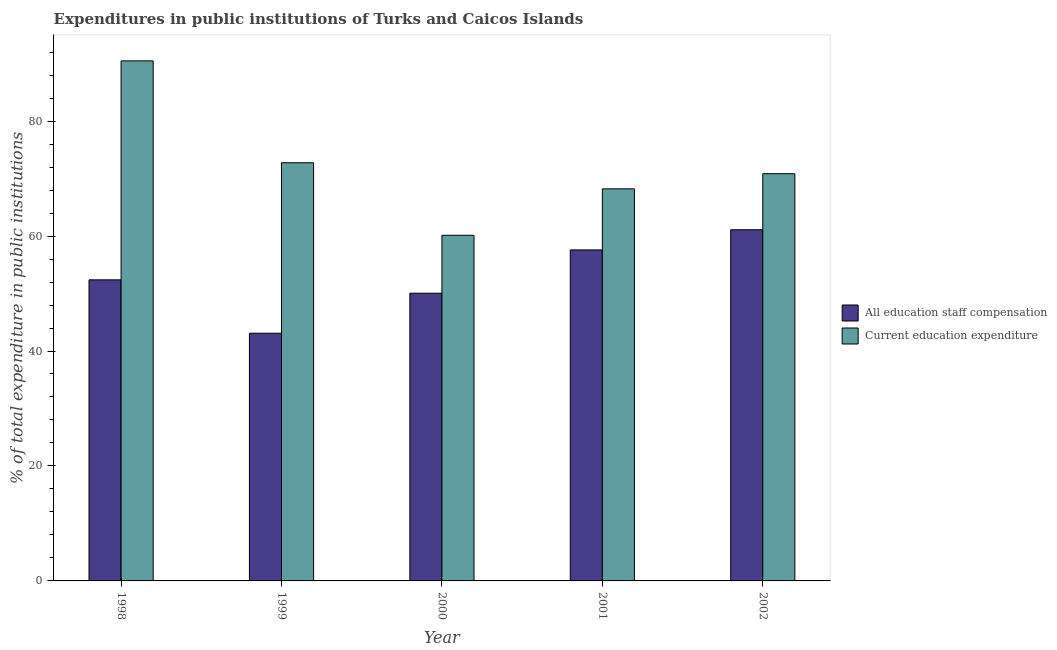How many different coloured bars are there?
Provide a short and direct response. 2. Are the number of bars per tick equal to the number of legend labels?
Your answer should be very brief. Yes. How many bars are there on the 5th tick from the left?
Make the answer very short. 2. What is the label of the 5th group of bars from the left?
Offer a very short reply. 2002. In how many cases, is the number of bars for a given year not equal to the number of legend labels?
Keep it short and to the point. 0. What is the expenditure in education in 2000?
Make the answer very short. 60.13. Across all years, what is the maximum expenditure in education?
Your answer should be very brief. 90.48. Across all years, what is the minimum expenditure in staff compensation?
Ensure brevity in your answer.  43.1. In which year was the expenditure in staff compensation maximum?
Ensure brevity in your answer.  2002. In which year was the expenditure in education minimum?
Keep it short and to the point. 2000. What is the total expenditure in staff compensation in the graph?
Give a very brief answer. 264.22. What is the difference between the expenditure in staff compensation in 2000 and that in 2001?
Your answer should be very brief. -7.53. What is the difference between the expenditure in staff compensation in 2000 and the expenditure in education in 2001?
Your response must be concise. -7.53. What is the average expenditure in staff compensation per year?
Provide a short and direct response. 52.84. What is the ratio of the expenditure in education in 1999 to that in 2001?
Ensure brevity in your answer.  1.07. Is the expenditure in staff compensation in 2000 less than that in 2001?
Provide a succinct answer. Yes. Is the difference between the expenditure in staff compensation in 1999 and 2000 greater than the difference between the expenditure in education in 1999 and 2000?
Ensure brevity in your answer.  No. What is the difference between the highest and the second highest expenditure in staff compensation?
Provide a succinct answer. 3.51. What is the difference between the highest and the lowest expenditure in staff compensation?
Provide a short and direct response. 18. What does the 1st bar from the left in 2000 represents?
Provide a short and direct response. All education staff compensation. What does the 2nd bar from the right in 2001 represents?
Offer a very short reply. All education staff compensation. Are all the bars in the graph horizontal?
Provide a succinct answer. No. What is the difference between two consecutive major ticks on the Y-axis?
Keep it short and to the point. 20. Are the values on the major ticks of Y-axis written in scientific E-notation?
Provide a short and direct response. No. Does the graph contain grids?
Offer a very short reply. No. Where does the legend appear in the graph?
Provide a short and direct response. Center right. What is the title of the graph?
Offer a very short reply. Expenditures in public institutions of Turks and Caicos Islands. Does "Fertility rate" appear as one of the legend labels in the graph?
Provide a short and direct response. No. What is the label or title of the Y-axis?
Ensure brevity in your answer.  % of total expenditure in public institutions. What is the % of total expenditure in public institutions in All education staff compensation in 1998?
Give a very brief answer. 52.38. What is the % of total expenditure in public institutions of Current education expenditure in 1998?
Your response must be concise. 90.48. What is the % of total expenditure in public institutions in All education staff compensation in 1999?
Provide a short and direct response. 43.1. What is the % of total expenditure in public institutions of Current education expenditure in 1999?
Your response must be concise. 72.75. What is the % of total expenditure in public institutions of All education staff compensation in 2000?
Make the answer very short. 50.06. What is the % of total expenditure in public institutions in Current education expenditure in 2000?
Offer a very short reply. 60.13. What is the % of total expenditure in public institutions in All education staff compensation in 2001?
Offer a very short reply. 57.59. What is the % of total expenditure in public institutions of Current education expenditure in 2001?
Keep it short and to the point. 68.21. What is the % of total expenditure in public institutions of All education staff compensation in 2002?
Keep it short and to the point. 61.1. What is the % of total expenditure in public institutions in Current education expenditure in 2002?
Ensure brevity in your answer.  70.85. Across all years, what is the maximum % of total expenditure in public institutions in All education staff compensation?
Provide a succinct answer. 61.1. Across all years, what is the maximum % of total expenditure in public institutions in Current education expenditure?
Your answer should be compact. 90.48. Across all years, what is the minimum % of total expenditure in public institutions in All education staff compensation?
Ensure brevity in your answer.  43.1. Across all years, what is the minimum % of total expenditure in public institutions in Current education expenditure?
Offer a very short reply. 60.13. What is the total % of total expenditure in public institutions in All education staff compensation in the graph?
Offer a very short reply. 264.22. What is the total % of total expenditure in public institutions in Current education expenditure in the graph?
Ensure brevity in your answer.  362.42. What is the difference between the % of total expenditure in public institutions in All education staff compensation in 1998 and that in 1999?
Make the answer very short. 9.28. What is the difference between the % of total expenditure in public institutions of Current education expenditure in 1998 and that in 1999?
Give a very brief answer. 17.72. What is the difference between the % of total expenditure in public institutions of All education staff compensation in 1998 and that in 2000?
Your answer should be very brief. 2.32. What is the difference between the % of total expenditure in public institutions in Current education expenditure in 1998 and that in 2000?
Your answer should be compact. 30.35. What is the difference between the % of total expenditure in public institutions in All education staff compensation in 1998 and that in 2001?
Provide a succinct answer. -5.21. What is the difference between the % of total expenditure in public institutions in Current education expenditure in 1998 and that in 2001?
Ensure brevity in your answer.  22.26. What is the difference between the % of total expenditure in public institutions in All education staff compensation in 1998 and that in 2002?
Make the answer very short. -8.72. What is the difference between the % of total expenditure in public institutions in Current education expenditure in 1998 and that in 2002?
Your answer should be compact. 19.63. What is the difference between the % of total expenditure in public institutions of All education staff compensation in 1999 and that in 2000?
Make the answer very short. -6.96. What is the difference between the % of total expenditure in public institutions in Current education expenditure in 1999 and that in 2000?
Your answer should be very brief. 12.62. What is the difference between the % of total expenditure in public institutions of All education staff compensation in 1999 and that in 2001?
Ensure brevity in your answer.  -14.49. What is the difference between the % of total expenditure in public institutions of Current education expenditure in 1999 and that in 2001?
Provide a short and direct response. 4.54. What is the difference between the % of total expenditure in public institutions of All education staff compensation in 1999 and that in 2002?
Your response must be concise. -18. What is the difference between the % of total expenditure in public institutions in Current education expenditure in 1999 and that in 2002?
Make the answer very short. 1.9. What is the difference between the % of total expenditure in public institutions in All education staff compensation in 2000 and that in 2001?
Your answer should be very brief. -7.53. What is the difference between the % of total expenditure in public institutions of Current education expenditure in 2000 and that in 2001?
Offer a very short reply. -8.08. What is the difference between the % of total expenditure in public institutions of All education staff compensation in 2000 and that in 2002?
Your response must be concise. -11.04. What is the difference between the % of total expenditure in public institutions in Current education expenditure in 2000 and that in 2002?
Offer a very short reply. -10.72. What is the difference between the % of total expenditure in public institutions in All education staff compensation in 2001 and that in 2002?
Ensure brevity in your answer.  -3.51. What is the difference between the % of total expenditure in public institutions in Current education expenditure in 2001 and that in 2002?
Give a very brief answer. -2.64. What is the difference between the % of total expenditure in public institutions of All education staff compensation in 1998 and the % of total expenditure in public institutions of Current education expenditure in 1999?
Keep it short and to the point. -20.37. What is the difference between the % of total expenditure in public institutions in All education staff compensation in 1998 and the % of total expenditure in public institutions in Current education expenditure in 2000?
Make the answer very short. -7.75. What is the difference between the % of total expenditure in public institutions in All education staff compensation in 1998 and the % of total expenditure in public institutions in Current education expenditure in 2001?
Provide a succinct answer. -15.83. What is the difference between the % of total expenditure in public institutions in All education staff compensation in 1998 and the % of total expenditure in public institutions in Current education expenditure in 2002?
Make the answer very short. -18.47. What is the difference between the % of total expenditure in public institutions of All education staff compensation in 1999 and the % of total expenditure in public institutions of Current education expenditure in 2000?
Your response must be concise. -17.03. What is the difference between the % of total expenditure in public institutions of All education staff compensation in 1999 and the % of total expenditure in public institutions of Current education expenditure in 2001?
Ensure brevity in your answer.  -25.12. What is the difference between the % of total expenditure in public institutions in All education staff compensation in 1999 and the % of total expenditure in public institutions in Current education expenditure in 2002?
Provide a short and direct response. -27.75. What is the difference between the % of total expenditure in public institutions of All education staff compensation in 2000 and the % of total expenditure in public institutions of Current education expenditure in 2001?
Give a very brief answer. -18.15. What is the difference between the % of total expenditure in public institutions of All education staff compensation in 2000 and the % of total expenditure in public institutions of Current education expenditure in 2002?
Your response must be concise. -20.79. What is the difference between the % of total expenditure in public institutions in All education staff compensation in 2001 and the % of total expenditure in public institutions in Current education expenditure in 2002?
Make the answer very short. -13.26. What is the average % of total expenditure in public institutions of All education staff compensation per year?
Your answer should be compact. 52.84. What is the average % of total expenditure in public institutions in Current education expenditure per year?
Provide a short and direct response. 72.48. In the year 1998, what is the difference between the % of total expenditure in public institutions in All education staff compensation and % of total expenditure in public institutions in Current education expenditure?
Provide a succinct answer. -38.1. In the year 1999, what is the difference between the % of total expenditure in public institutions in All education staff compensation and % of total expenditure in public institutions in Current education expenditure?
Ensure brevity in your answer.  -29.66. In the year 2000, what is the difference between the % of total expenditure in public institutions in All education staff compensation and % of total expenditure in public institutions in Current education expenditure?
Offer a very short reply. -10.07. In the year 2001, what is the difference between the % of total expenditure in public institutions in All education staff compensation and % of total expenditure in public institutions in Current education expenditure?
Offer a terse response. -10.63. In the year 2002, what is the difference between the % of total expenditure in public institutions of All education staff compensation and % of total expenditure in public institutions of Current education expenditure?
Make the answer very short. -9.75. What is the ratio of the % of total expenditure in public institutions of All education staff compensation in 1998 to that in 1999?
Offer a terse response. 1.22. What is the ratio of the % of total expenditure in public institutions in Current education expenditure in 1998 to that in 1999?
Keep it short and to the point. 1.24. What is the ratio of the % of total expenditure in public institutions in All education staff compensation in 1998 to that in 2000?
Your answer should be compact. 1.05. What is the ratio of the % of total expenditure in public institutions of Current education expenditure in 1998 to that in 2000?
Your answer should be very brief. 1.5. What is the ratio of the % of total expenditure in public institutions in All education staff compensation in 1998 to that in 2001?
Make the answer very short. 0.91. What is the ratio of the % of total expenditure in public institutions in Current education expenditure in 1998 to that in 2001?
Make the answer very short. 1.33. What is the ratio of the % of total expenditure in public institutions in All education staff compensation in 1998 to that in 2002?
Your answer should be very brief. 0.86. What is the ratio of the % of total expenditure in public institutions in Current education expenditure in 1998 to that in 2002?
Provide a succinct answer. 1.28. What is the ratio of the % of total expenditure in public institutions of All education staff compensation in 1999 to that in 2000?
Provide a short and direct response. 0.86. What is the ratio of the % of total expenditure in public institutions in Current education expenditure in 1999 to that in 2000?
Offer a very short reply. 1.21. What is the ratio of the % of total expenditure in public institutions in All education staff compensation in 1999 to that in 2001?
Offer a very short reply. 0.75. What is the ratio of the % of total expenditure in public institutions of Current education expenditure in 1999 to that in 2001?
Provide a succinct answer. 1.07. What is the ratio of the % of total expenditure in public institutions in All education staff compensation in 1999 to that in 2002?
Your answer should be very brief. 0.71. What is the ratio of the % of total expenditure in public institutions in Current education expenditure in 1999 to that in 2002?
Provide a short and direct response. 1.03. What is the ratio of the % of total expenditure in public institutions in All education staff compensation in 2000 to that in 2001?
Give a very brief answer. 0.87. What is the ratio of the % of total expenditure in public institutions of Current education expenditure in 2000 to that in 2001?
Offer a very short reply. 0.88. What is the ratio of the % of total expenditure in public institutions in All education staff compensation in 2000 to that in 2002?
Your answer should be compact. 0.82. What is the ratio of the % of total expenditure in public institutions of Current education expenditure in 2000 to that in 2002?
Make the answer very short. 0.85. What is the ratio of the % of total expenditure in public institutions in All education staff compensation in 2001 to that in 2002?
Ensure brevity in your answer.  0.94. What is the ratio of the % of total expenditure in public institutions of Current education expenditure in 2001 to that in 2002?
Offer a very short reply. 0.96. What is the difference between the highest and the second highest % of total expenditure in public institutions in All education staff compensation?
Ensure brevity in your answer.  3.51. What is the difference between the highest and the second highest % of total expenditure in public institutions in Current education expenditure?
Keep it short and to the point. 17.72. What is the difference between the highest and the lowest % of total expenditure in public institutions of All education staff compensation?
Make the answer very short. 18. What is the difference between the highest and the lowest % of total expenditure in public institutions of Current education expenditure?
Give a very brief answer. 30.35. 